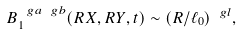<formula> <loc_0><loc_0><loc_500><loc_500>B _ { 1 } ^ { \ g a \ g b } ( R X , R Y , t ) \sim ( R / \ell _ { 0 } ) ^ { \ g l } ,</formula> 